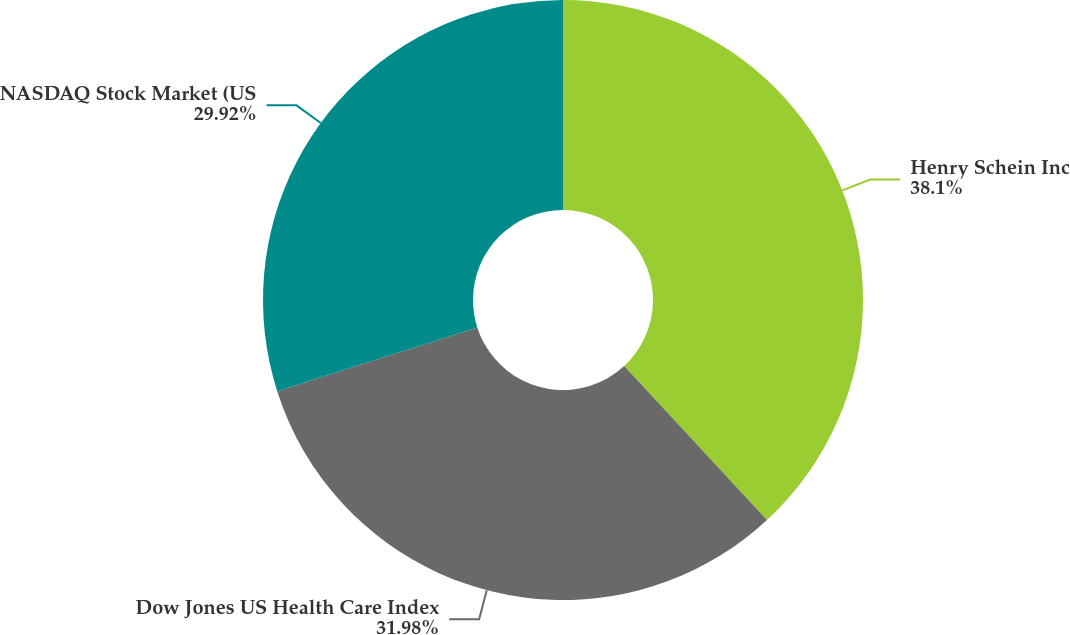Convert chart to OTSL. <chart><loc_0><loc_0><loc_500><loc_500><pie_chart><fcel>Henry Schein Inc<fcel>Dow Jones US Health Care Index<fcel>NASDAQ Stock Market (US<nl><fcel>38.1%<fcel>31.98%<fcel>29.92%<nl></chart> 